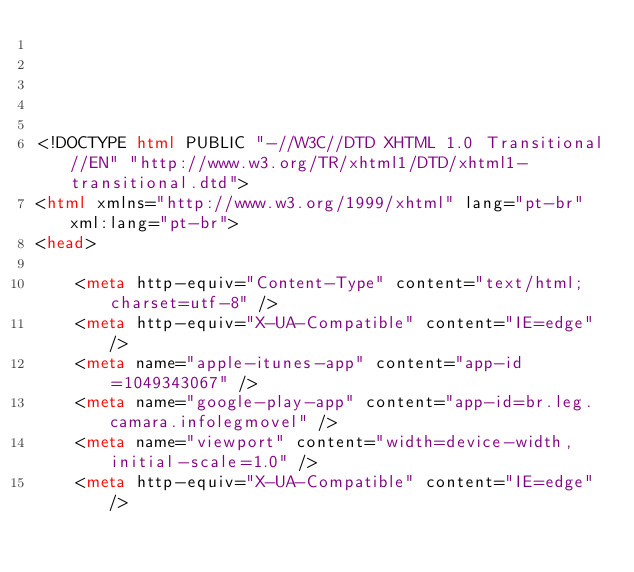Convert code to text. <code><loc_0><loc_0><loc_500><loc_500><_HTML_>




<!DOCTYPE html PUBLIC "-//W3C//DTD XHTML 1.0 Transitional//EN" "http://www.w3.org/TR/xhtml1/DTD/xhtml1-transitional.dtd">
<html xmlns="http://www.w3.org/1999/xhtml" lang="pt-br" xml:lang="pt-br">
<head>
	    
    <meta http-equiv="Content-Type" content="text/html; charset=utf-8" />
    <meta http-equiv="X-UA-Compatible" content="IE=edge" />
    <meta name="apple-itunes-app" content="app-id=1049343067" />
    <meta name="google-play-app" content="app-id=br.leg.camara.infolegmovel" />
    <meta name="viewport" content="width=device-width, initial-scale=1.0" />
	<meta http-equiv="X-UA-Compatible" content="IE=edge" /> 
    </code> 